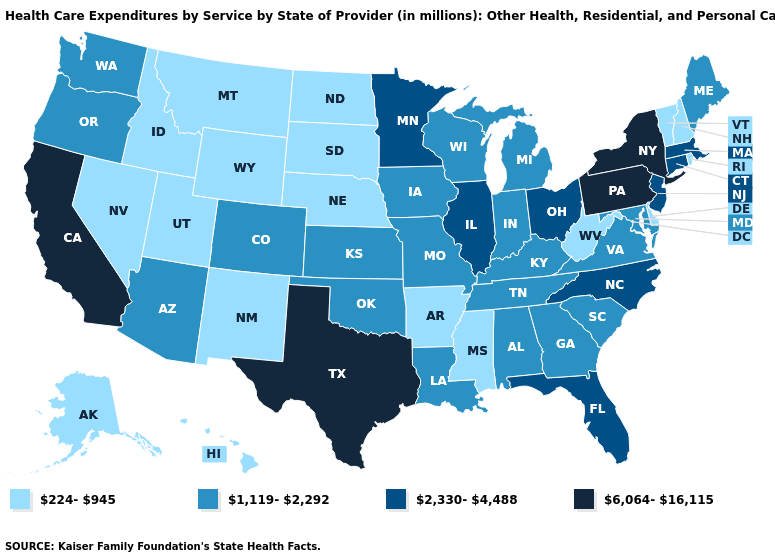Does Louisiana have a higher value than Connecticut?
Answer briefly. No. Name the states that have a value in the range 224-945?
Answer briefly. Alaska, Arkansas, Delaware, Hawaii, Idaho, Mississippi, Montana, Nebraska, Nevada, New Hampshire, New Mexico, North Dakota, Rhode Island, South Dakota, Utah, Vermont, West Virginia, Wyoming. How many symbols are there in the legend?
Concise answer only. 4. What is the value of Michigan?
Quick response, please. 1,119-2,292. Name the states that have a value in the range 1,119-2,292?
Concise answer only. Alabama, Arizona, Colorado, Georgia, Indiana, Iowa, Kansas, Kentucky, Louisiana, Maine, Maryland, Michigan, Missouri, Oklahoma, Oregon, South Carolina, Tennessee, Virginia, Washington, Wisconsin. What is the value of Mississippi?
Be succinct. 224-945. Does Colorado have a lower value than Pennsylvania?
Concise answer only. Yes. Name the states that have a value in the range 1,119-2,292?
Give a very brief answer. Alabama, Arizona, Colorado, Georgia, Indiana, Iowa, Kansas, Kentucky, Louisiana, Maine, Maryland, Michigan, Missouri, Oklahoma, Oregon, South Carolina, Tennessee, Virginia, Washington, Wisconsin. Does Wyoming have a lower value than New Hampshire?
Write a very short answer. No. How many symbols are there in the legend?
Keep it brief. 4. What is the value of Tennessee?
Write a very short answer. 1,119-2,292. Does the map have missing data?
Quick response, please. No. Does New York have the highest value in the USA?
Answer briefly. Yes. Does the first symbol in the legend represent the smallest category?
Give a very brief answer. Yes. Name the states that have a value in the range 1,119-2,292?
Answer briefly. Alabama, Arizona, Colorado, Georgia, Indiana, Iowa, Kansas, Kentucky, Louisiana, Maine, Maryland, Michigan, Missouri, Oklahoma, Oregon, South Carolina, Tennessee, Virginia, Washington, Wisconsin. 